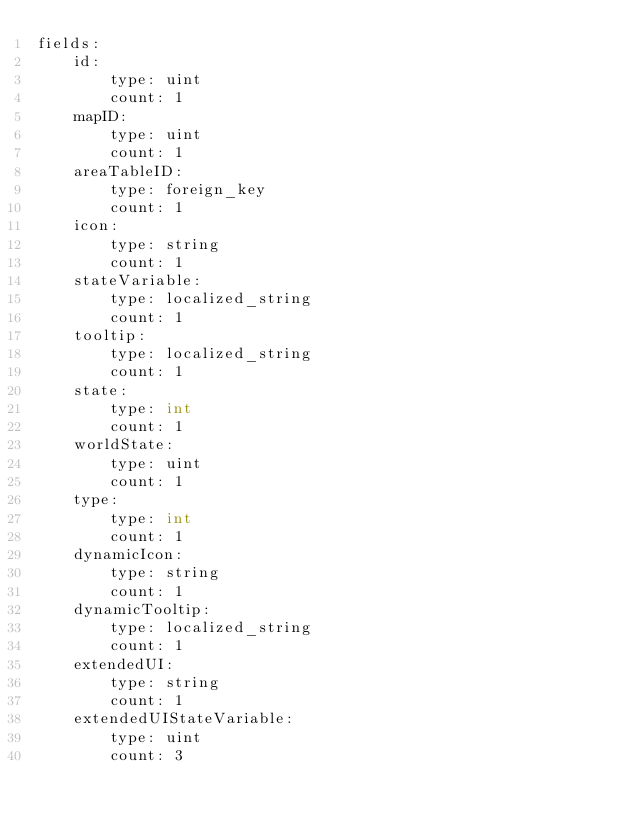Convert code to text. <code><loc_0><loc_0><loc_500><loc_500><_YAML_>fields:
    id:
        type: uint
        count: 1
    mapID:
        type: uint
        count: 1
    areaTableID:
        type: foreign_key
        count: 1
    icon:
        type: string
        count: 1
    stateVariable:
        type: localized_string
        count: 1
    tooltip:
        type: localized_string
        count: 1
    state:
        type: int
        count: 1
    worldState:
        type: uint
        count: 1
    type:
        type: int
        count: 1
    dynamicIcon:
        type: string
        count: 1
    dynamicTooltip:
        type: localized_string
        count: 1
    extendedUI:
        type: string
        count: 1
    extendedUIStateVariable:
        type: uint
        count: 3
</code> 